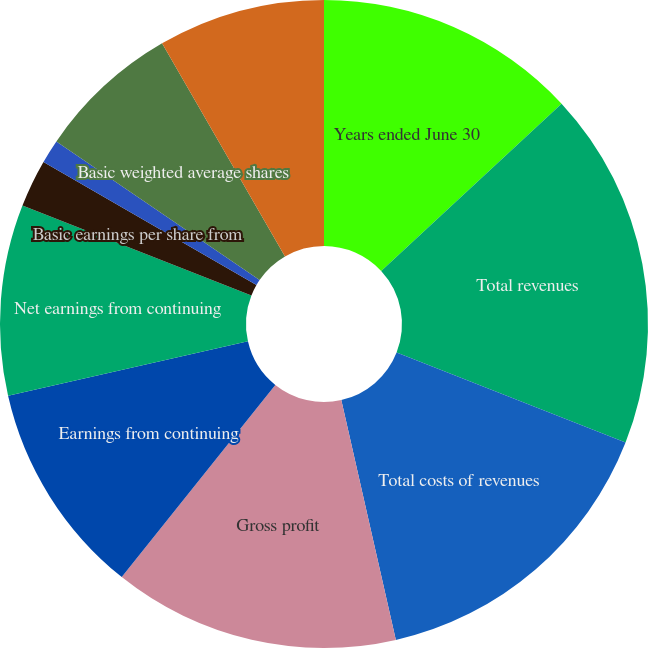Convert chart. <chart><loc_0><loc_0><loc_500><loc_500><pie_chart><fcel>Years ended June 30<fcel>Total revenues<fcel>Total costs of revenues<fcel>Gross profit<fcel>Earnings from continuing<fcel>Net earnings from continuing<fcel>Basic earnings per share from<fcel>Diluted earnings per share<fcel>Basic weighted average shares<fcel>Diluted weighted average<nl><fcel>13.1%<fcel>17.86%<fcel>15.48%<fcel>14.29%<fcel>10.71%<fcel>9.52%<fcel>2.38%<fcel>1.19%<fcel>7.14%<fcel>8.33%<nl></chart> 